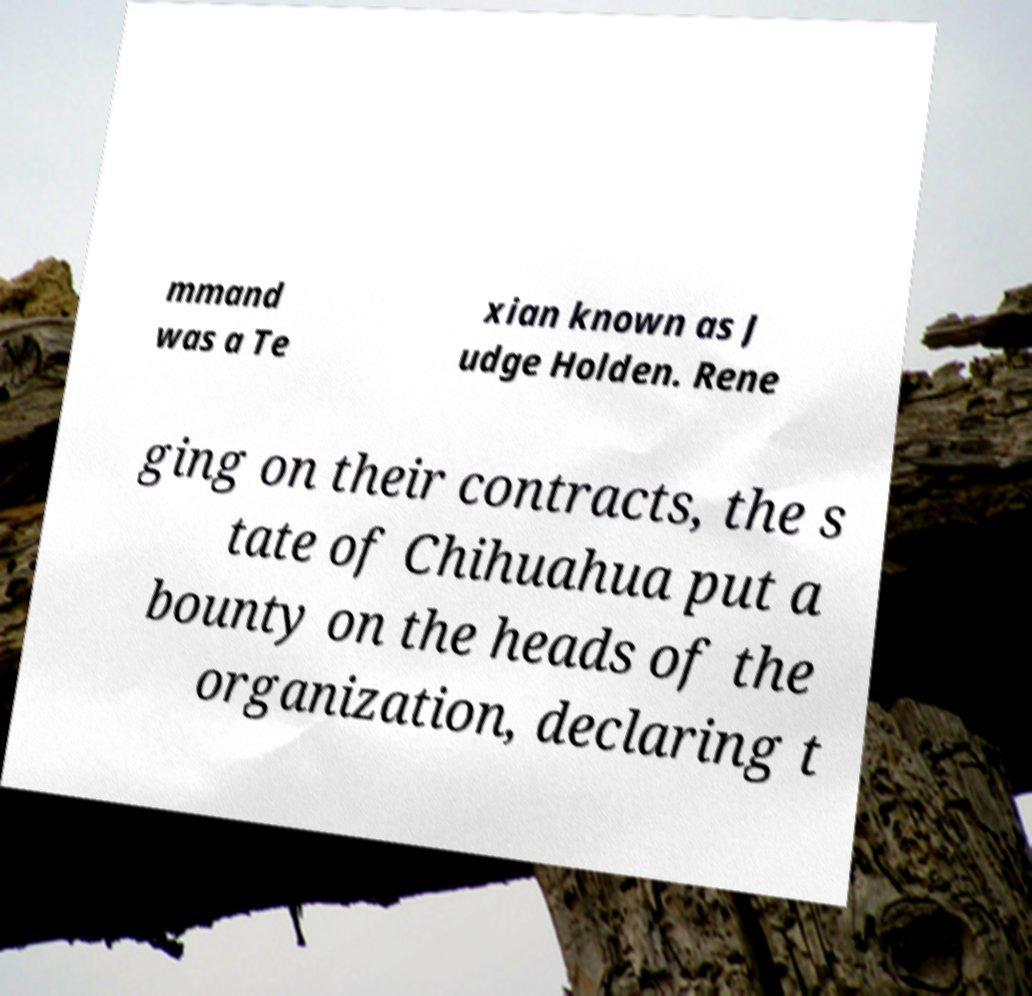Can you read and provide the text displayed in the image?This photo seems to have some interesting text. Can you extract and type it out for me? mmand was a Te xian known as J udge Holden. Rene ging on their contracts, the s tate of Chihuahua put a bounty on the heads of the organization, declaring t 